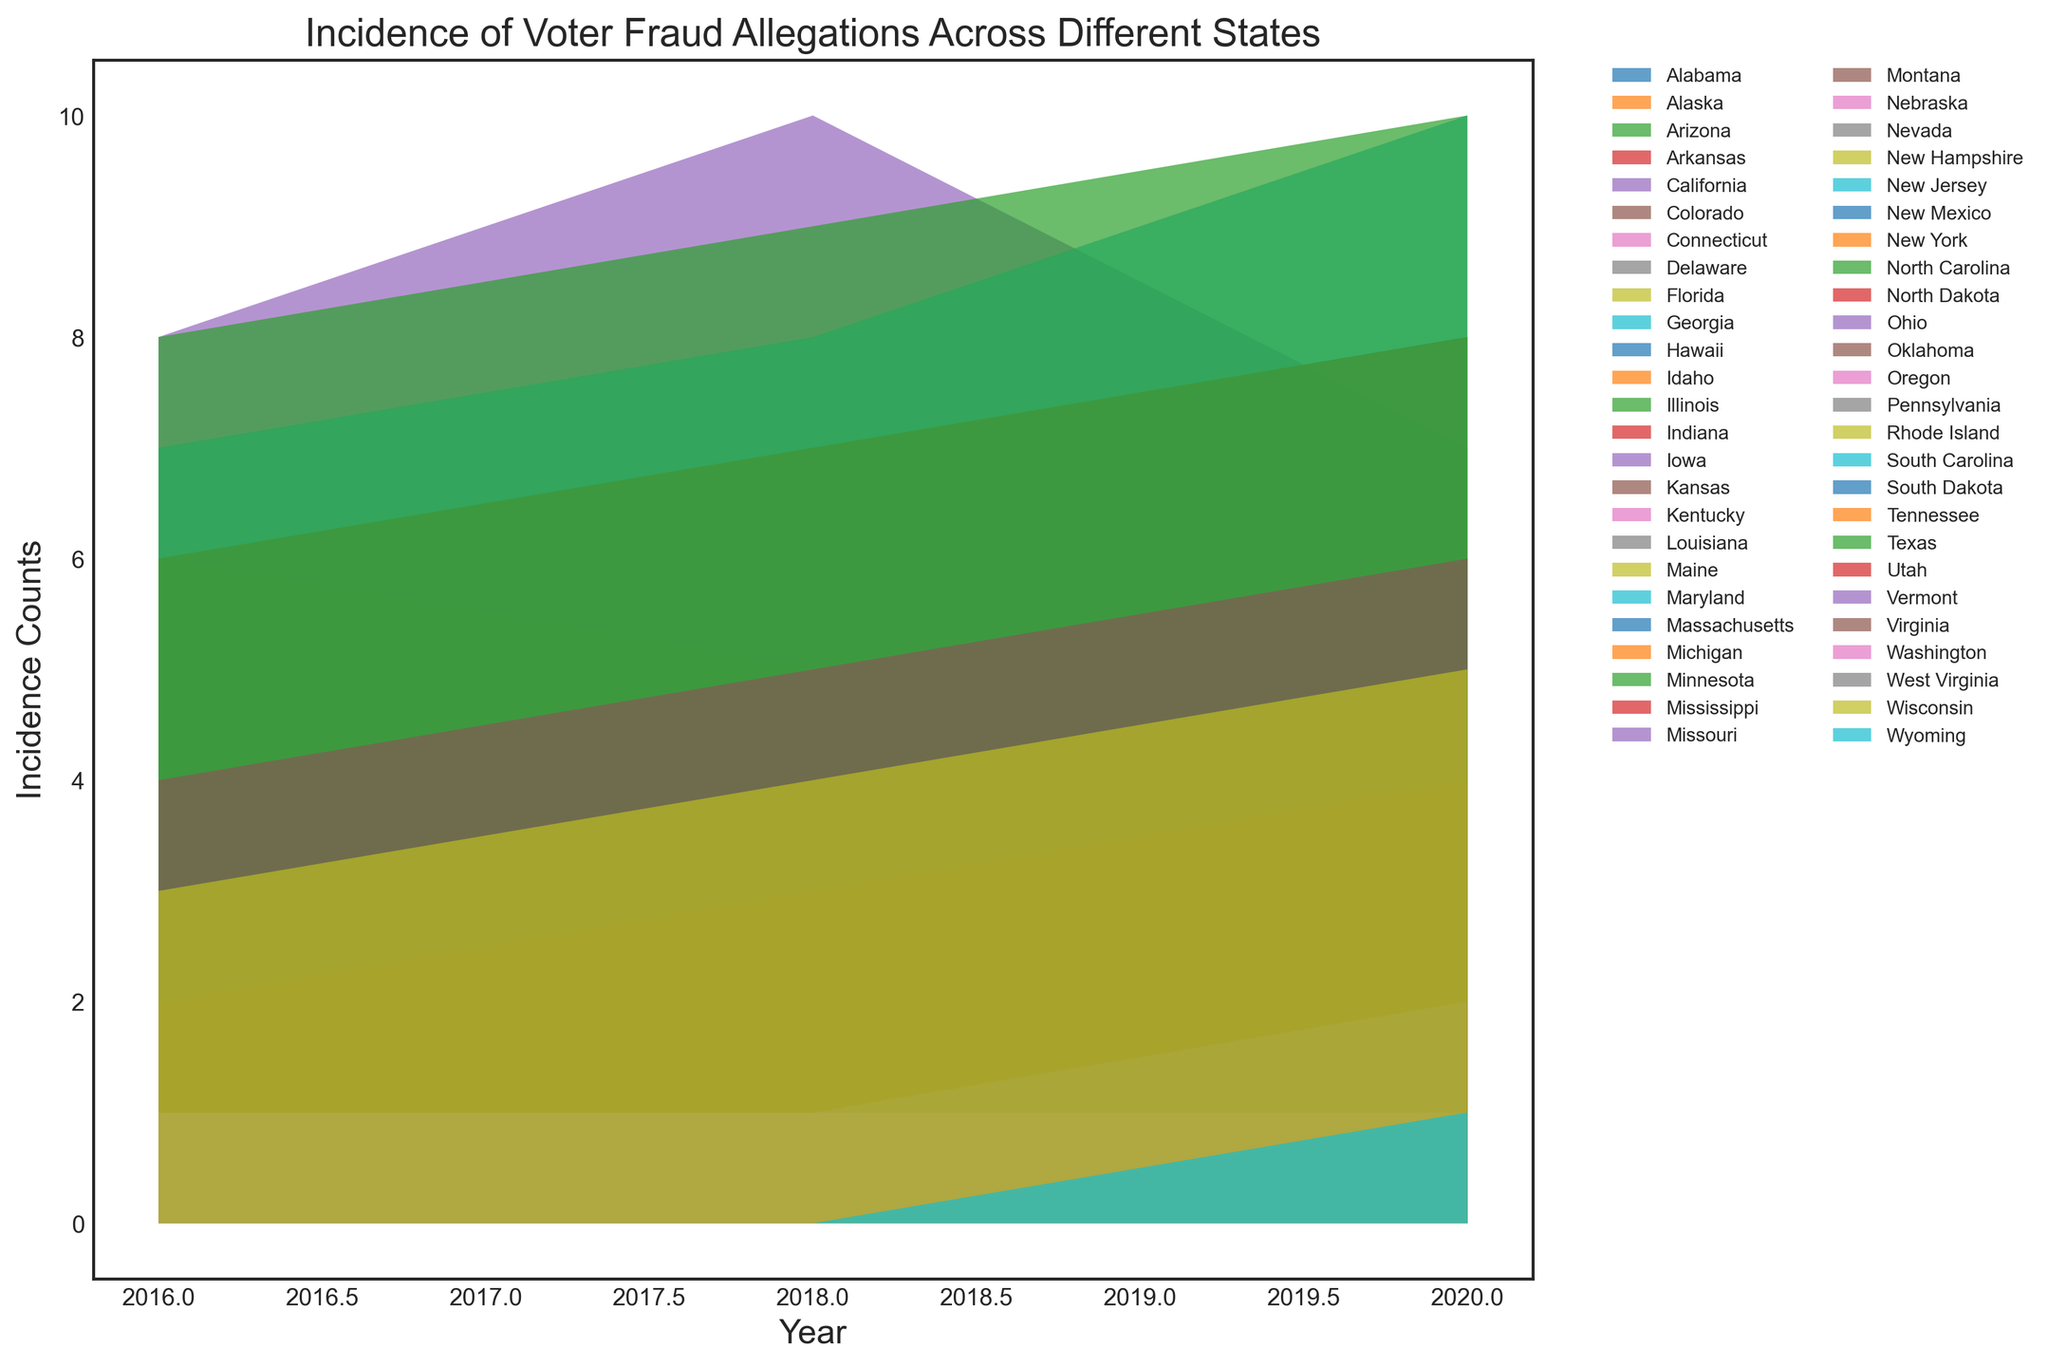What state has the highest incidence of voter fraud allegations in 2020? To determine which state has the highest incidence of voter fraud allegations in 2020, observe the height of the areas representing each state at the year 2020. The tallest area for 2020 represents the state with the highest counts.
Answer: Georgia How did the incidence of voter fraud allegations in Florida change from 2016 to 2020? To assess the change, compare the heights of the area representing Florida for the years 2016 and 2020. The height at 2020 should be subtracted from the height at 2016.
Answer: Increased by 2 Which state had a consistent incidence count of voter fraud allegations across all three years? Identify the states where the visual representation height remains the same for the years 2016, 2018, and 2020.
Answer: Kansas How many states had zero voter fraud allegations in 2016? Count the number of states where the area representing them starts at zero for the year 2016.
Answer: 7 states Which state showed a decrease in voter fraud allegations from 2018 to 2020? Compare the areas for each state at the years 2018 and 2020 and look for any states where the area height decreases.
Answer: California What is the average incidence of voter fraud allegations in Alabama for the years 2016, 2018, and 2020? To find the average, add the incidence counts for Alabama for 2016, 2018, and 2020, then divide by 3: (5 + 7 + 6) / 3.
Answer: 6 Which states had exactly one count of voter fraud allegations in 2020? Look at the areas for the year 2020 and identify the states where the height corresponds to 1.
Answer: Alaska, Connecticut, Maine, Massachusetts, Montana, Nebraska, New Hampshire, New Mexico, North Dakota, Oregon, South Dakota, Washington, Wyoming How many states had an increase in incidence counts from both 2016 to 2018 and 2018 to 2020? Identify the states where the areas increase from 2016 to 2018 and also from 2018 to 2020.
Answer: Georgia, Texas, North Carolina, Louisiana, Ohio, Wisconsin What is the difference in incidence counts between Texas and Ohio in 2020? Determine the incidence counts for Texas and Ohio in 2020 and subtract the smaller count from the larger one: 10 (Texas) - 6 (Ohio).
Answer: 4 Which state had the largest increase in voter fraud allegations from 2016 to 2020? Calculate the difference in incidence counts between 2016 and 2020 for each state and identify the state with the largest difference.
Answer: Georgia 